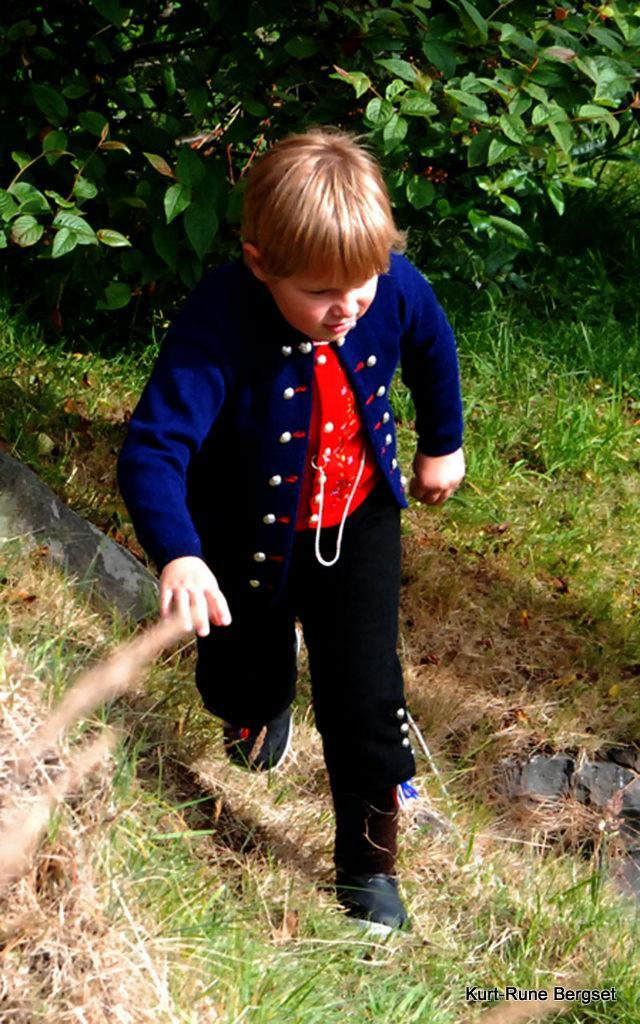Who is the main subject in the image? There is a boy in the image. What is the boy doing in the image? The boy is walking on a path. What type of terrain is visible under the boy's feet? Grass is visible on the ground. What can be seen in the background of the image? There are plants in the background of the image. What word does the boy say as he walks on the path? There is no indication in the image of what the boy might be saying, so it cannot be determined from the picture. 